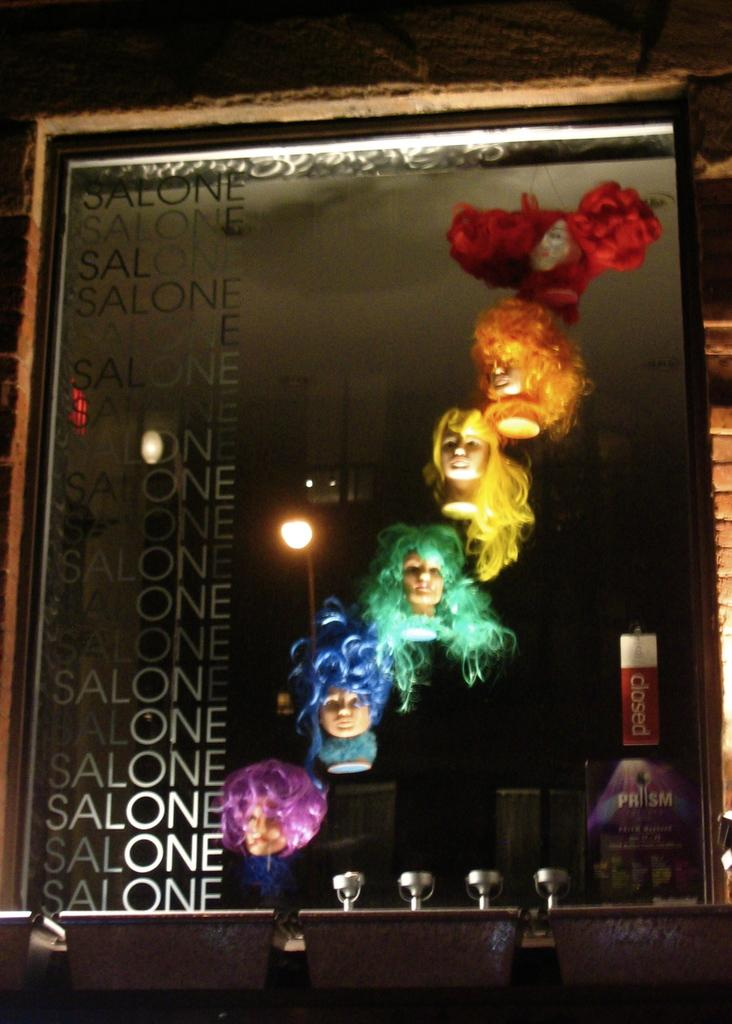What object in the image reflects images? There is a mirror in the image that reflects images. What can be seen in the mirror? The faces of dolls are visible in the mirror. What is located beside the mirror? There is a wall beside the mirror. What objects are at the bottom of the image? There are boxes at the bottom of the image. What type of fruit is being played with on the floor in the image? There is no fruit or floor visible in the image; it only shows a mirror, doll faces, a wall, and boxes. 